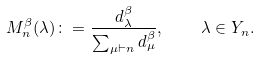Convert formula to latex. <formula><loc_0><loc_0><loc_500><loc_500>M ^ { \beta } _ { n } ( \lambda ) \colon = \frac { d _ { \lambda } ^ { \beta } } { \sum _ { \mu \vdash n } d _ { \mu } ^ { \beta } } , \quad \lambda \in Y _ { n } .</formula> 